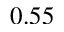Convert formula to latex. <formula><loc_0><loc_0><loc_500><loc_500>0 . 5 5</formula> 